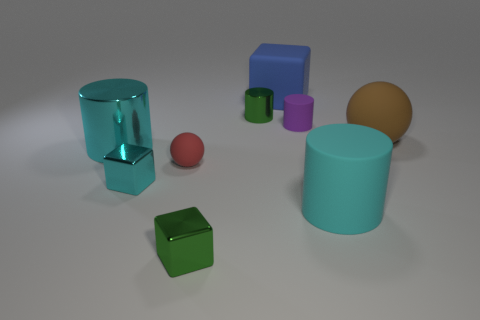Are there fewer big green balls than brown matte things?
Offer a terse response. Yes. Is there anything else that has the same color as the small shiny cylinder?
Ensure brevity in your answer.  Yes. What shape is the tiny green metallic object that is behind the cyan block?
Offer a very short reply. Cylinder. There is a tiny metal cylinder; does it have the same color as the ball that is behind the big metallic object?
Your answer should be very brief. No. Are there the same number of tiny matte balls in front of the brown matte object and blue things right of the blue cube?
Your answer should be compact. No. What number of other objects are there of the same size as the red ball?
Keep it short and to the point. 4. The red thing has what size?
Give a very brief answer. Small. Do the small green cube and the tiny green thing behind the big rubber cylinder have the same material?
Ensure brevity in your answer.  Yes. Are there any small red rubber objects that have the same shape as the brown matte object?
Ensure brevity in your answer.  Yes. There is a cyan object that is the same size as the cyan matte cylinder; what material is it?
Offer a very short reply. Metal. 